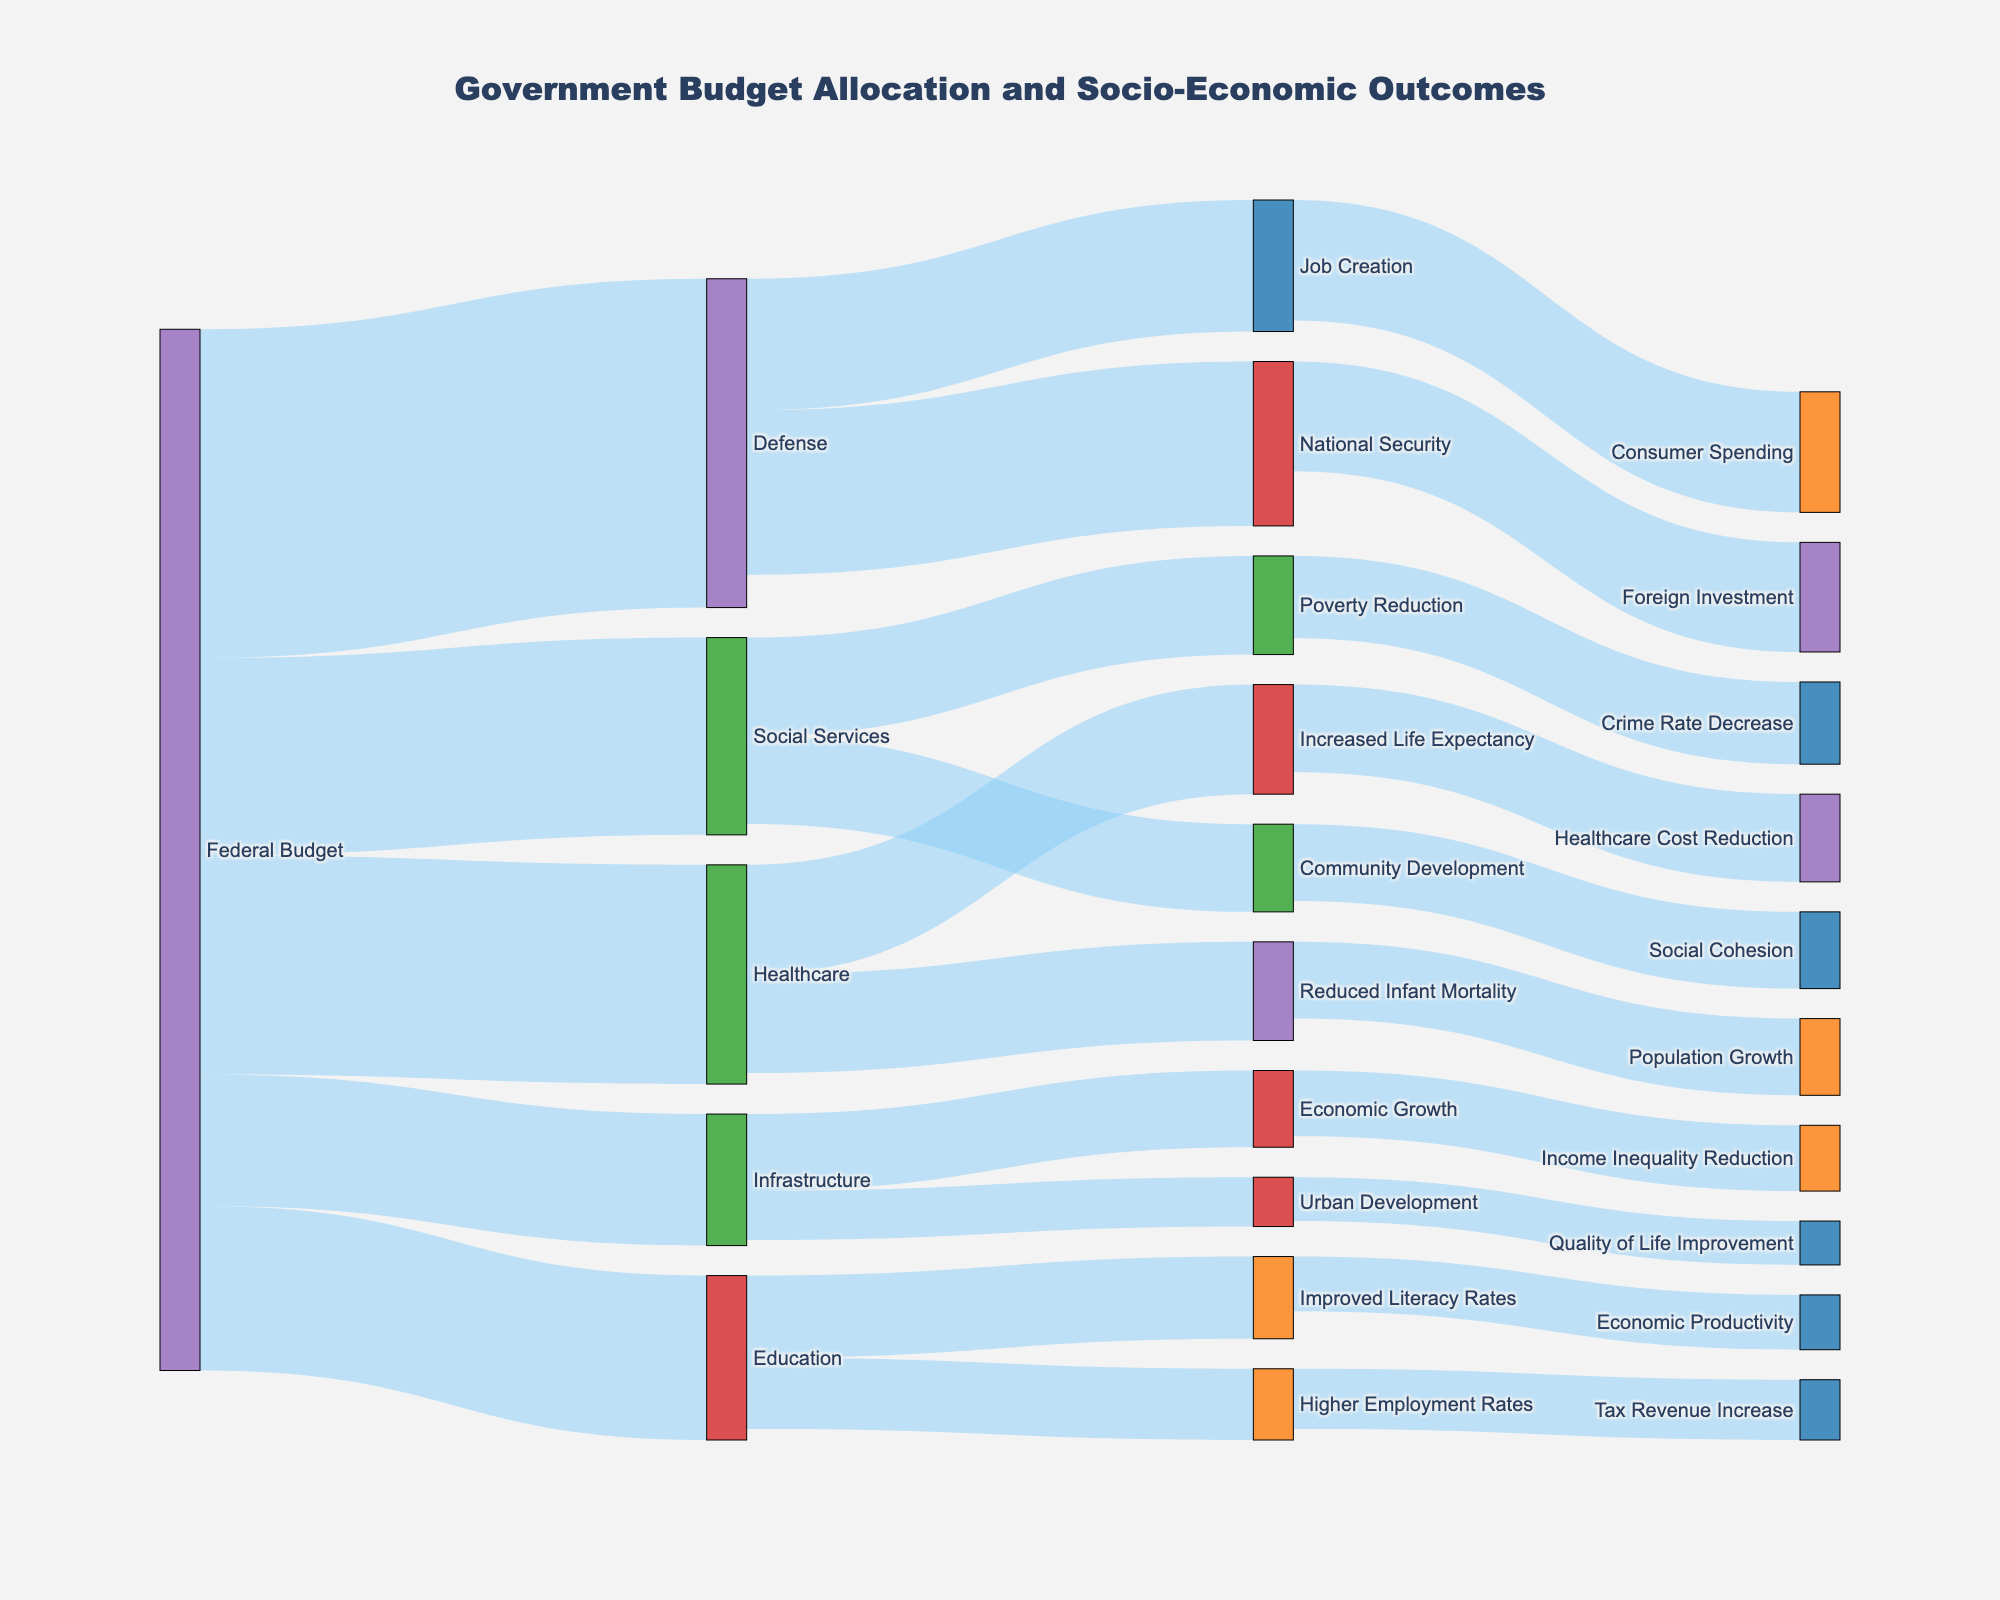How much is allocated to Healthcare from the Federal Budget? The sankey diagram shows a link from the "Federal Budget" node to the "Healthcare" node with a value of 200 indicated.
Answer: 200 Which sector receives the highest allocation from the Federal Budget? By looking at the links extending from the "Federal Budget" node, "Defense" has the highest value of 300.
Answer: Defense What are the socio-economic outcomes linked to the Education sector? The links going out from the "Education" node connect to "Improved Literacy Rates" and "Higher Employment Rates".
Answer: Improved Literacy Rates, Higher Employment Rates How much combined allocation do Education and Healthcare receive from the Federal Budget? From the diagram, Education receives 150 and Healthcare receives 200. Adding these values, 150 + 200 = 350.
Answer: 350 Which socio-economic outcome has the greatest value under the Defense sector? The sankey diagram shows two outcomes under Defense: "National Security" with a value of 150 and "Job Creation" with a value of 120. "National Security" has the greater value.
Answer: National Security What is the total value directed towards "Economic Productivity" and "Tax Revenue Increase" through Education? From "Improved Literacy Rates", 50 is directed towards "Economic Productivity". From "Higher Employment Rates", 55 is directed towards "Tax Revenue Increase". Adding these values, 50 + 55 = 105.
Answer: 105 Does Urban Development receive a higher allocation compared to Community Development? Comparing the values from the diagram, Community Development receives 80 and Urban Development receives 45. Therefore, Community Development receives a higher allocation.
Answer: No Which sector has the direct outcome of "Healthcare Cost Reduction"? Following the link from the figure, "Healthcare" leads directly to "Healthcare Cost Reduction".
Answer: Healthcare What is the total value allocated for outcomes improving Economic Growth and Urban Development? The value directed towards Economic Growth from Infrastructure is 70, and towards Urban Development is 45. Adding these values, 70 + 45 = 115.
Answer: 115 What outcome is associated with both "Community Development" and "Poverty Reduction"? The outcomes from "Community Development" and "Poverty Reduction" are "Social Cohesion" and "Crime Rate Decrease", respectively. No outcome is shared between these two initiatives.
Answer: None 